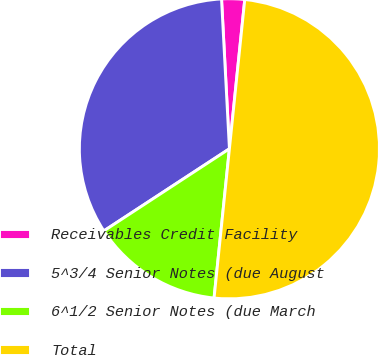Convert chart to OTSL. <chart><loc_0><loc_0><loc_500><loc_500><pie_chart><fcel>Receivables Credit Facility<fcel>5^3/4 Senior Notes (due August<fcel>6^1/2 Senior Notes (due March<fcel>Total<nl><fcel>2.47%<fcel>33.38%<fcel>14.15%<fcel>50.0%<nl></chart> 